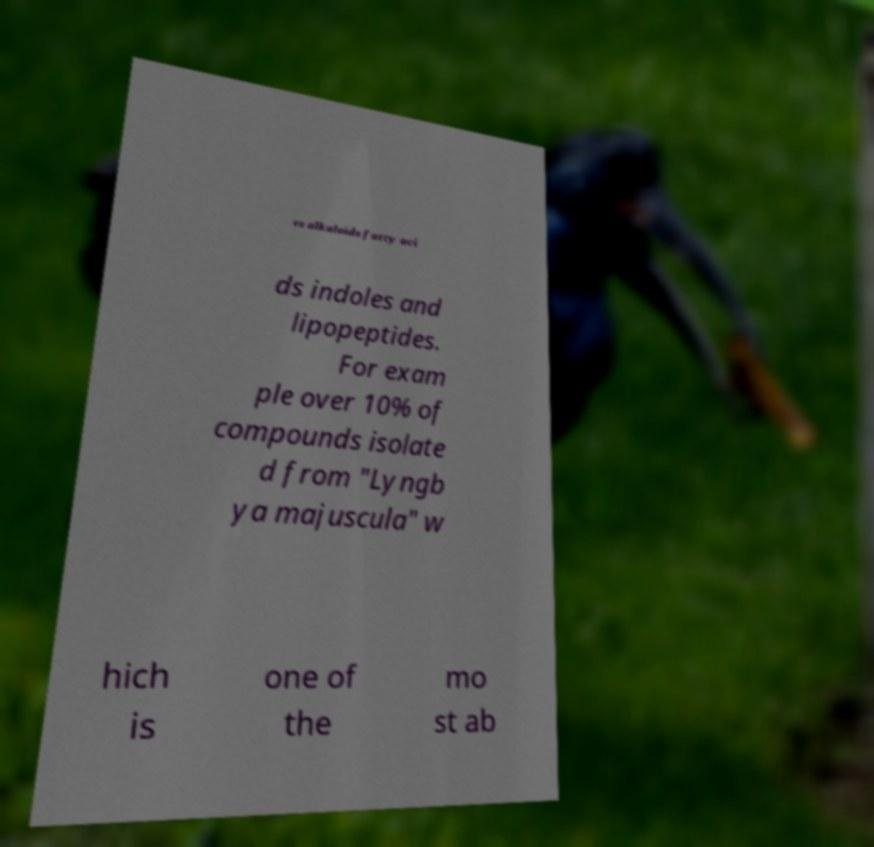There's text embedded in this image that I need extracted. Can you transcribe it verbatim? es alkaloids fatty aci ds indoles and lipopeptides. For exam ple over 10% of compounds isolate d from "Lyngb ya majuscula" w hich is one of the mo st ab 